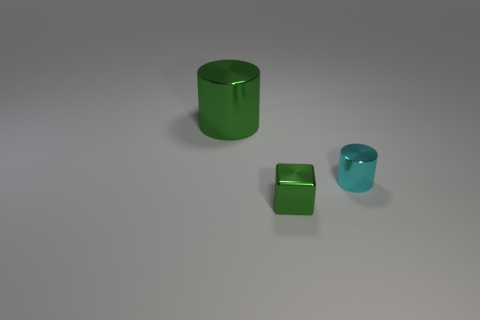Add 3 big green cylinders. How many objects exist? 6 Subtract all cubes. How many objects are left? 2 Subtract all tiny green cubes. Subtract all small green shiny cubes. How many objects are left? 1 Add 1 big green things. How many big green things are left? 2 Add 3 tiny red things. How many tiny red things exist? 3 Subtract 1 cyan cylinders. How many objects are left? 2 Subtract all red blocks. Subtract all brown balls. How many blocks are left? 1 